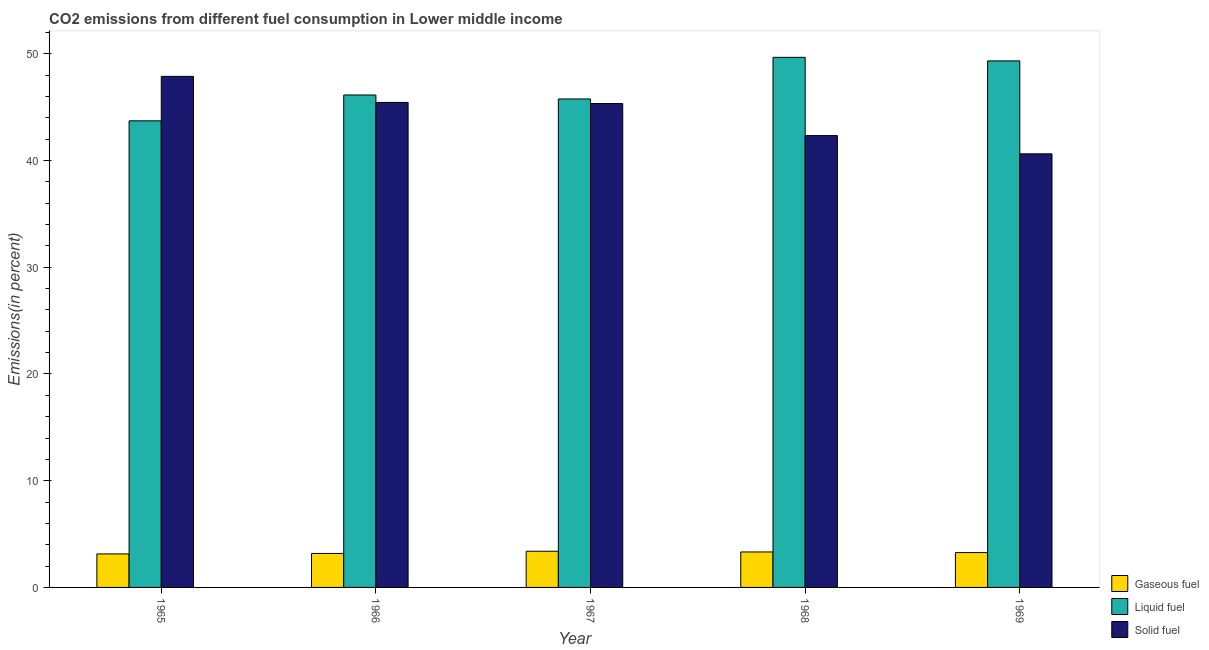Are the number of bars on each tick of the X-axis equal?
Your answer should be very brief. Yes. How many bars are there on the 1st tick from the left?
Ensure brevity in your answer.  3. How many bars are there on the 4th tick from the right?
Provide a short and direct response. 3. What is the label of the 3rd group of bars from the left?
Keep it short and to the point. 1967. In how many cases, is the number of bars for a given year not equal to the number of legend labels?
Offer a terse response. 0. What is the percentage of gaseous fuel emission in 1965?
Make the answer very short. 3.14. Across all years, what is the maximum percentage of solid fuel emission?
Your response must be concise. 47.89. Across all years, what is the minimum percentage of liquid fuel emission?
Make the answer very short. 43.72. In which year was the percentage of gaseous fuel emission maximum?
Ensure brevity in your answer.  1967. In which year was the percentage of liquid fuel emission minimum?
Your response must be concise. 1965. What is the total percentage of liquid fuel emission in the graph?
Provide a short and direct response. 234.65. What is the difference between the percentage of gaseous fuel emission in 1965 and that in 1968?
Make the answer very short. -0.18. What is the difference between the percentage of solid fuel emission in 1966 and the percentage of gaseous fuel emission in 1969?
Make the answer very short. 4.82. What is the average percentage of liquid fuel emission per year?
Your answer should be compact. 46.93. In the year 1965, what is the difference between the percentage of liquid fuel emission and percentage of gaseous fuel emission?
Give a very brief answer. 0. In how many years, is the percentage of solid fuel emission greater than 34 %?
Provide a succinct answer. 5. What is the ratio of the percentage of solid fuel emission in 1968 to that in 1969?
Your answer should be compact. 1.04. Is the percentage of solid fuel emission in 1965 less than that in 1969?
Your response must be concise. No. What is the difference between the highest and the second highest percentage of solid fuel emission?
Keep it short and to the point. 2.44. What is the difference between the highest and the lowest percentage of liquid fuel emission?
Offer a terse response. 5.95. Is the sum of the percentage of solid fuel emission in 1967 and 1968 greater than the maximum percentage of liquid fuel emission across all years?
Offer a very short reply. Yes. What does the 2nd bar from the left in 1967 represents?
Provide a short and direct response. Liquid fuel. What does the 2nd bar from the right in 1969 represents?
Your answer should be compact. Liquid fuel. Are all the bars in the graph horizontal?
Keep it short and to the point. No. How many years are there in the graph?
Give a very brief answer. 5. What is the difference between two consecutive major ticks on the Y-axis?
Your answer should be compact. 10. Does the graph contain any zero values?
Offer a terse response. No. Where does the legend appear in the graph?
Your answer should be compact. Bottom right. How are the legend labels stacked?
Offer a very short reply. Vertical. What is the title of the graph?
Your answer should be very brief. CO2 emissions from different fuel consumption in Lower middle income. What is the label or title of the Y-axis?
Your answer should be compact. Emissions(in percent). What is the Emissions(in percent) in Gaseous fuel in 1965?
Provide a short and direct response. 3.14. What is the Emissions(in percent) of Liquid fuel in 1965?
Ensure brevity in your answer.  43.72. What is the Emissions(in percent) of Solid fuel in 1965?
Provide a succinct answer. 47.89. What is the Emissions(in percent) of Gaseous fuel in 1966?
Make the answer very short. 3.18. What is the Emissions(in percent) of Liquid fuel in 1966?
Ensure brevity in your answer.  46.14. What is the Emissions(in percent) in Solid fuel in 1966?
Keep it short and to the point. 45.45. What is the Emissions(in percent) in Gaseous fuel in 1967?
Your response must be concise. 3.39. What is the Emissions(in percent) in Liquid fuel in 1967?
Your answer should be very brief. 45.77. What is the Emissions(in percent) in Solid fuel in 1967?
Keep it short and to the point. 45.34. What is the Emissions(in percent) in Gaseous fuel in 1968?
Your answer should be compact. 3.32. What is the Emissions(in percent) of Liquid fuel in 1968?
Your answer should be very brief. 49.67. What is the Emissions(in percent) in Solid fuel in 1968?
Make the answer very short. 42.34. What is the Emissions(in percent) of Gaseous fuel in 1969?
Your answer should be very brief. 3.26. What is the Emissions(in percent) in Liquid fuel in 1969?
Ensure brevity in your answer.  49.34. What is the Emissions(in percent) of Solid fuel in 1969?
Make the answer very short. 40.63. Across all years, what is the maximum Emissions(in percent) of Gaseous fuel?
Offer a very short reply. 3.39. Across all years, what is the maximum Emissions(in percent) of Liquid fuel?
Keep it short and to the point. 49.67. Across all years, what is the maximum Emissions(in percent) in Solid fuel?
Offer a very short reply. 47.89. Across all years, what is the minimum Emissions(in percent) of Gaseous fuel?
Provide a short and direct response. 3.14. Across all years, what is the minimum Emissions(in percent) in Liquid fuel?
Provide a short and direct response. 43.72. Across all years, what is the minimum Emissions(in percent) in Solid fuel?
Your answer should be compact. 40.63. What is the total Emissions(in percent) of Gaseous fuel in the graph?
Keep it short and to the point. 16.3. What is the total Emissions(in percent) of Liquid fuel in the graph?
Keep it short and to the point. 234.65. What is the total Emissions(in percent) in Solid fuel in the graph?
Keep it short and to the point. 221.65. What is the difference between the Emissions(in percent) in Gaseous fuel in 1965 and that in 1966?
Make the answer very short. -0.05. What is the difference between the Emissions(in percent) of Liquid fuel in 1965 and that in 1966?
Provide a short and direct response. -2.42. What is the difference between the Emissions(in percent) of Solid fuel in 1965 and that in 1966?
Ensure brevity in your answer.  2.44. What is the difference between the Emissions(in percent) in Gaseous fuel in 1965 and that in 1967?
Offer a terse response. -0.25. What is the difference between the Emissions(in percent) in Liquid fuel in 1965 and that in 1967?
Keep it short and to the point. -2.05. What is the difference between the Emissions(in percent) of Solid fuel in 1965 and that in 1967?
Offer a terse response. 2.55. What is the difference between the Emissions(in percent) of Gaseous fuel in 1965 and that in 1968?
Provide a short and direct response. -0.18. What is the difference between the Emissions(in percent) in Liquid fuel in 1965 and that in 1968?
Give a very brief answer. -5.95. What is the difference between the Emissions(in percent) of Solid fuel in 1965 and that in 1968?
Your response must be concise. 5.55. What is the difference between the Emissions(in percent) in Gaseous fuel in 1965 and that in 1969?
Your response must be concise. -0.13. What is the difference between the Emissions(in percent) in Liquid fuel in 1965 and that in 1969?
Your answer should be compact. -5.62. What is the difference between the Emissions(in percent) in Solid fuel in 1965 and that in 1969?
Ensure brevity in your answer.  7.26. What is the difference between the Emissions(in percent) of Gaseous fuel in 1966 and that in 1967?
Ensure brevity in your answer.  -0.21. What is the difference between the Emissions(in percent) of Liquid fuel in 1966 and that in 1967?
Provide a short and direct response. 0.37. What is the difference between the Emissions(in percent) in Solid fuel in 1966 and that in 1967?
Make the answer very short. 0.11. What is the difference between the Emissions(in percent) in Gaseous fuel in 1966 and that in 1968?
Ensure brevity in your answer.  -0.14. What is the difference between the Emissions(in percent) in Liquid fuel in 1966 and that in 1968?
Keep it short and to the point. -3.53. What is the difference between the Emissions(in percent) in Solid fuel in 1966 and that in 1968?
Your answer should be compact. 3.11. What is the difference between the Emissions(in percent) of Gaseous fuel in 1966 and that in 1969?
Keep it short and to the point. -0.08. What is the difference between the Emissions(in percent) in Liquid fuel in 1966 and that in 1969?
Your answer should be compact. -3.2. What is the difference between the Emissions(in percent) in Solid fuel in 1966 and that in 1969?
Give a very brief answer. 4.82. What is the difference between the Emissions(in percent) in Gaseous fuel in 1967 and that in 1968?
Provide a short and direct response. 0.07. What is the difference between the Emissions(in percent) of Liquid fuel in 1967 and that in 1968?
Give a very brief answer. -3.9. What is the difference between the Emissions(in percent) in Solid fuel in 1967 and that in 1968?
Provide a succinct answer. 3. What is the difference between the Emissions(in percent) of Gaseous fuel in 1967 and that in 1969?
Offer a terse response. 0.13. What is the difference between the Emissions(in percent) of Liquid fuel in 1967 and that in 1969?
Your answer should be very brief. -3.57. What is the difference between the Emissions(in percent) of Solid fuel in 1967 and that in 1969?
Offer a very short reply. 4.71. What is the difference between the Emissions(in percent) in Gaseous fuel in 1968 and that in 1969?
Provide a short and direct response. 0.06. What is the difference between the Emissions(in percent) of Liquid fuel in 1968 and that in 1969?
Offer a very short reply. 0.33. What is the difference between the Emissions(in percent) of Solid fuel in 1968 and that in 1969?
Offer a very short reply. 1.71. What is the difference between the Emissions(in percent) in Gaseous fuel in 1965 and the Emissions(in percent) in Liquid fuel in 1966?
Provide a succinct answer. -43.01. What is the difference between the Emissions(in percent) of Gaseous fuel in 1965 and the Emissions(in percent) of Solid fuel in 1966?
Your answer should be very brief. -42.31. What is the difference between the Emissions(in percent) of Liquid fuel in 1965 and the Emissions(in percent) of Solid fuel in 1966?
Keep it short and to the point. -1.73. What is the difference between the Emissions(in percent) of Gaseous fuel in 1965 and the Emissions(in percent) of Liquid fuel in 1967?
Ensure brevity in your answer.  -42.63. What is the difference between the Emissions(in percent) of Gaseous fuel in 1965 and the Emissions(in percent) of Solid fuel in 1967?
Provide a short and direct response. -42.21. What is the difference between the Emissions(in percent) in Liquid fuel in 1965 and the Emissions(in percent) in Solid fuel in 1967?
Ensure brevity in your answer.  -1.62. What is the difference between the Emissions(in percent) of Gaseous fuel in 1965 and the Emissions(in percent) of Liquid fuel in 1968?
Keep it short and to the point. -46.53. What is the difference between the Emissions(in percent) in Gaseous fuel in 1965 and the Emissions(in percent) in Solid fuel in 1968?
Provide a short and direct response. -39.2. What is the difference between the Emissions(in percent) of Liquid fuel in 1965 and the Emissions(in percent) of Solid fuel in 1968?
Offer a terse response. 1.38. What is the difference between the Emissions(in percent) in Gaseous fuel in 1965 and the Emissions(in percent) in Liquid fuel in 1969?
Provide a short and direct response. -46.2. What is the difference between the Emissions(in percent) in Gaseous fuel in 1965 and the Emissions(in percent) in Solid fuel in 1969?
Make the answer very short. -37.49. What is the difference between the Emissions(in percent) of Liquid fuel in 1965 and the Emissions(in percent) of Solid fuel in 1969?
Keep it short and to the point. 3.09. What is the difference between the Emissions(in percent) in Gaseous fuel in 1966 and the Emissions(in percent) in Liquid fuel in 1967?
Your response must be concise. -42.59. What is the difference between the Emissions(in percent) in Gaseous fuel in 1966 and the Emissions(in percent) in Solid fuel in 1967?
Your answer should be compact. -42.16. What is the difference between the Emissions(in percent) of Gaseous fuel in 1966 and the Emissions(in percent) of Liquid fuel in 1968?
Offer a terse response. -46.49. What is the difference between the Emissions(in percent) in Gaseous fuel in 1966 and the Emissions(in percent) in Solid fuel in 1968?
Your answer should be very brief. -39.16. What is the difference between the Emissions(in percent) of Liquid fuel in 1966 and the Emissions(in percent) of Solid fuel in 1968?
Provide a short and direct response. 3.8. What is the difference between the Emissions(in percent) in Gaseous fuel in 1966 and the Emissions(in percent) in Liquid fuel in 1969?
Your answer should be compact. -46.16. What is the difference between the Emissions(in percent) of Gaseous fuel in 1966 and the Emissions(in percent) of Solid fuel in 1969?
Provide a succinct answer. -37.45. What is the difference between the Emissions(in percent) in Liquid fuel in 1966 and the Emissions(in percent) in Solid fuel in 1969?
Keep it short and to the point. 5.51. What is the difference between the Emissions(in percent) in Gaseous fuel in 1967 and the Emissions(in percent) in Liquid fuel in 1968?
Provide a short and direct response. -46.28. What is the difference between the Emissions(in percent) of Gaseous fuel in 1967 and the Emissions(in percent) of Solid fuel in 1968?
Provide a succinct answer. -38.95. What is the difference between the Emissions(in percent) in Liquid fuel in 1967 and the Emissions(in percent) in Solid fuel in 1968?
Offer a very short reply. 3.43. What is the difference between the Emissions(in percent) in Gaseous fuel in 1967 and the Emissions(in percent) in Liquid fuel in 1969?
Ensure brevity in your answer.  -45.95. What is the difference between the Emissions(in percent) of Gaseous fuel in 1967 and the Emissions(in percent) of Solid fuel in 1969?
Provide a short and direct response. -37.24. What is the difference between the Emissions(in percent) in Liquid fuel in 1967 and the Emissions(in percent) in Solid fuel in 1969?
Your answer should be compact. 5.14. What is the difference between the Emissions(in percent) in Gaseous fuel in 1968 and the Emissions(in percent) in Liquid fuel in 1969?
Offer a very short reply. -46.02. What is the difference between the Emissions(in percent) in Gaseous fuel in 1968 and the Emissions(in percent) in Solid fuel in 1969?
Ensure brevity in your answer.  -37.31. What is the difference between the Emissions(in percent) in Liquid fuel in 1968 and the Emissions(in percent) in Solid fuel in 1969?
Provide a succinct answer. 9.04. What is the average Emissions(in percent) of Gaseous fuel per year?
Make the answer very short. 3.26. What is the average Emissions(in percent) in Liquid fuel per year?
Your response must be concise. 46.93. What is the average Emissions(in percent) of Solid fuel per year?
Provide a succinct answer. 44.33. In the year 1965, what is the difference between the Emissions(in percent) in Gaseous fuel and Emissions(in percent) in Liquid fuel?
Your answer should be very brief. -40.58. In the year 1965, what is the difference between the Emissions(in percent) of Gaseous fuel and Emissions(in percent) of Solid fuel?
Your answer should be compact. -44.75. In the year 1965, what is the difference between the Emissions(in percent) of Liquid fuel and Emissions(in percent) of Solid fuel?
Ensure brevity in your answer.  -4.17. In the year 1966, what is the difference between the Emissions(in percent) in Gaseous fuel and Emissions(in percent) in Liquid fuel?
Your answer should be compact. -42.96. In the year 1966, what is the difference between the Emissions(in percent) in Gaseous fuel and Emissions(in percent) in Solid fuel?
Your response must be concise. -42.27. In the year 1966, what is the difference between the Emissions(in percent) of Liquid fuel and Emissions(in percent) of Solid fuel?
Make the answer very short. 0.69. In the year 1967, what is the difference between the Emissions(in percent) in Gaseous fuel and Emissions(in percent) in Liquid fuel?
Ensure brevity in your answer.  -42.38. In the year 1967, what is the difference between the Emissions(in percent) of Gaseous fuel and Emissions(in percent) of Solid fuel?
Provide a short and direct response. -41.95. In the year 1967, what is the difference between the Emissions(in percent) in Liquid fuel and Emissions(in percent) in Solid fuel?
Provide a short and direct response. 0.43. In the year 1968, what is the difference between the Emissions(in percent) of Gaseous fuel and Emissions(in percent) of Liquid fuel?
Your answer should be compact. -46.35. In the year 1968, what is the difference between the Emissions(in percent) of Gaseous fuel and Emissions(in percent) of Solid fuel?
Your answer should be very brief. -39.02. In the year 1968, what is the difference between the Emissions(in percent) in Liquid fuel and Emissions(in percent) in Solid fuel?
Your answer should be compact. 7.33. In the year 1969, what is the difference between the Emissions(in percent) in Gaseous fuel and Emissions(in percent) in Liquid fuel?
Give a very brief answer. -46.08. In the year 1969, what is the difference between the Emissions(in percent) in Gaseous fuel and Emissions(in percent) in Solid fuel?
Provide a short and direct response. -37.37. In the year 1969, what is the difference between the Emissions(in percent) in Liquid fuel and Emissions(in percent) in Solid fuel?
Your answer should be compact. 8.71. What is the ratio of the Emissions(in percent) in Gaseous fuel in 1965 to that in 1966?
Ensure brevity in your answer.  0.99. What is the ratio of the Emissions(in percent) of Liquid fuel in 1965 to that in 1966?
Provide a short and direct response. 0.95. What is the ratio of the Emissions(in percent) in Solid fuel in 1965 to that in 1966?
Offer a terse response. 1.05. What is the ratio of the Emissions(in percent) in Gaseous fuel in 1965 to that in 1967?
Provide a succinct answer. 0.93. What is the ratio of the Emissions(in percent) in Liquid fuel in 1965 to that in 1967?
Keep it short and to the point. 0.96. What is the ratio of the Emissions(in percent) in Solid fuel in 1965 to that in 1967?
Your answer should be compact. 1.06. What is the ratio of the Emissions(in percent) of Gaseous fuel in 1965 to that in 1968?
Provide a succinct answer. 0.94. What is the ratio of the Emissions(in percent) in Liquid fuel in 1965 to that in 1968?
Provide a short and direct response. 0.88. What is the ratio of the Emissions(in percent) of Solid fuel in 1965 to that in 1968?
Offer a very short reply. 1.13. What is the ratio of the Emissions(in percent) of Gaseous fuel in 1965 to that in 1969?
Offer a terse response. 0.96. What is the ratio of the Emissions(in percent) of Liquid fuel in 1965 to that in 1969?
Provide a short and direct response. 0.89. What is the ratio of the Emissions(in percent) in Solid fuel in 1965 to that in 1969?
Keep it short and to the point. 1.18. What is the ratio of the Emissions(in percent) in Gaseous fuel in 1966 to that in 1967?
Your answer should be compact. 0.94. What is the ratio of the Emissions(in percent) in Gaseous fuel in 1966 to that in 1968?
Your answer should be compact. 0.96. What is the ratio of the Emissions(in percent) of Liquid fuel in 1966 to that in 1968?
Keep it short and to the point. 0.93. What is the ratio of the Emissions(in percent) in Solid fuel in 1966 to that in 1968?
Your answer should be compact. 1.07. What is the ratio of the Emissions(in percent) in Gaseous fuel in 1966 to that in 1969?
Offer a very short reply. 0.98. What is the ratio of the Emissions(in percent) of Liquid fuel in 1966 to that in 1969?
Your response must be concise. 0.94. What is the ratio of the Emissions(in percent) in Solid fuel in 1966 to that in 1969?
Provide a succinct answer. 1.12. What is the ratio of the Emissions(in percent) in Gaseous fuel in 1967 to that in 1968?
Give a very brief answer. 1.02. What is the ratio of the Emissions(in percent) in Liquid fuel in 1967 to that in 1968?
Offer a terse response. 0.92. What is the ratio of the Emissions(in percent) of Solid fuel in 1967 to that in 1968?
Offer a very short reply. 1.07. What is the ratio of the Emissions(in percent) in Gaseous fuel in 1967 to that in 1969?
Your answer should be compact. 1.04. What is the ratio of the Emissions(in percent) in Liquid fuel in 1967 to that in 1969?
Make the answer very short. 0.93. What is the ratio of the Emissions(in percent) in Solid fuel in 1967 to that in 1969?
Keep it short and to the point. 1.12. What is the ratio of the Emissions(in percent) of Gaseous fuel in 1968 to that in 1969?
Give a very brief answer. 1.02. What is the ratio of the Emissions(in percent) in Liquid fuel in 1968 to that in 1969?
Your response must be concise. 1.01. What is the ratio of the Emissions(in percent) of Solid fuel in 1968 to that in 1969?
Give a very brief answer. 1.04. What is the difference between the highest and the second highest Emissions(in percent) of Gaseous fuel?
Ensure brevity in your answer.  0.07. What is the difference between the highest and the second highest Emissions(in percent) in Liquid fuel?
Provide a short and direct response. 0.33. What is the difference between the highest and the second highest Emissions(in percent) in Solid fuel?
Provide a succinct answer. 2.44. What is the difference between the highest and the lowest Emissions(in percent) of Gaseous fuel?
Your response must be concise. 0.25. What is the difference between the highest and the lowest Emissions(in percent) in Liquid fuel?
Keep it short and to the point. 5.95. What is the difference between the highest and the lowest Emissions(in percent) of Solid fuel?
Your answer should be very brief. 7.26. 